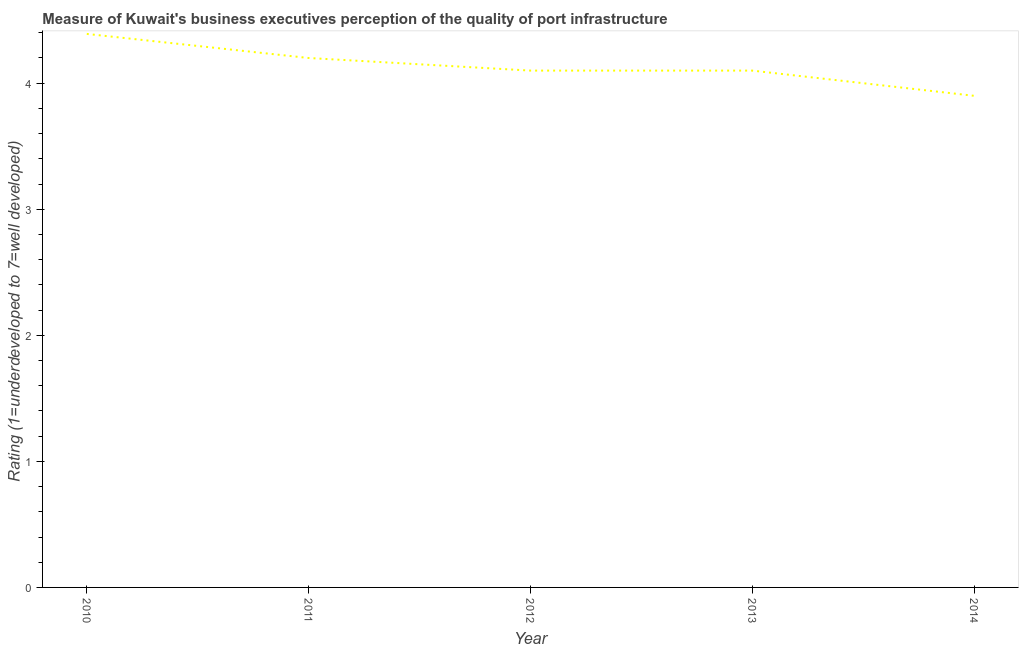Across all years, what is the maximum rating measuring quality of port infrastructure?
Provide a succinct answer. 4.39. Across all years, what is the minimum rating measuring quality of port infrastructure?
Make the answer very short. 3.9. In which year was the rating measuring quality of port infrastructure maximum?
Provide a short and direct response. 2010. What is the sum of the rating measuring quality of port infrastructure?
Your answer should be very brief. 20.69. What is the difference between the rating measuring quality of port infrastructure in 2011 and 2012?
Keep it short and to the point. 0.1. What is the average rating measuring quality of port infrastructure per year?
Provide a succinct answer. 4.14. What is the median rating measuring quality of port infrastructure?
Give a very brief answer. 4.1. In how many years, is the rating measuring quality of port infrastructure greater than 1.6 ?
Offer a terse response. 5. Do a majority of the years between 2010 and 2014 (inclusive) have rating measuring quality of port infrastructure greater than 1.4 ?
Provide a succinct answer. Yes. What is the ratio of the rating measuring quality of port infrastructure in 2012 to that in 2014?
Provide a short and direct response. 1.05. Is the difference between the rating measuring quality of port infrastructure in 2011 and 2014 greater than the difference between any two years?
Offer a terse response. No. What is the difference between the highest and the second highest rating measuring quality of port infrastructure?
Provide a short and direct response. 0.19. What is the difference between the highest and the lowest rating measuring quality of port infrastructure?
Your answer should be very brief. 0.49. In how many years, is the rating measuring quality of port infrastructure greater than the average rating measuring quality of port infrastructure taken over all years?
Offer a terse response. 2. What is the difference between two consecutive major ticks on the Y-axis?
Offer a terse response. 1. Does the graph contain any zero values?
Provide a short and direct response. No. Does the graph contain grids?
Give a very brief answer. No. What is the title of the graph?
Make the answer very short. Measure of Kuwait's business executives perception of the quality of port infrastructure. What is the label or title of the X-axis?
Your response must be concise. Year. What is the label or title of the Y-axis?
Keep it short and to the point. Rating (1=underdeveloped to 7=well developed) . What is the Rating (1=underdeveloped to 7=well developed)  of 2010?
Offer a very short reply. 4.39. What is the Rating (1=underdeveloped to 7=well developed)  in 2011?
Give a very brief answer. 4.2. What is the Rating (1=underdeveloped to 7=well developed)  of 2014?
Provide a succinct answer. 3.9. What is the difference between the Rating (1=underdeveloped to 7=well developed)  in 2010 and 2011?
Keep it short and to the point. 0.19. What is the difference between the Rating (1=underdeveloped to 7=well developed)  in 2010 and 2012?
Your response must be concise. 0.29. What is the difference between the Rating (1=underdeveloped to 7=well developed)  in 2010 and 2013?
Provide a short and direct response. 0.29. What is the difference between the Rating (1=underdeveloped to 7=well developed)  in 2010 and 2014?
Offer a terse response. 0.49. What is the difference between the Rating (1=underdeveloped to 7=well developed)  in 2011 and 2012?
Provide a short and direct response. 0.1. What is the difference between the Rating (1=underdeveloped to 7=well developed)  in 2012 and 2013?
Offer a terse response. 0. What is the difference between the Rating (1=underdeveloped to 7=well developed)  in 2012 and 2014?
Give a very brief answer. 0.2. What is the ratio of the Rating (1=underdeveloped to 7=well developed)  in 2010 to that in 2011?
Make the answer very short. 1.04. What is the ratio of the Rating (1=underdeveloped to 7=well developed)  in 2010 to that in 2012?
Keep it short and to the point. 1.07. What is the ratio of the Rating (1=underdeveloped to 7=well developed)  in 2010 to that in 2013?
Provide a succinct answer. 1.07. What is the ratio of the Rating (1=underdeveloped to 7=well developed)  in 2010 to that in 2014?
Provide a short and direct response. 1.13. What is the ratio of the Rating (1=underdeveloped to 7=well developed)  in 2011 to that in 2013?
Give a very brief answer. 1.02. What is the ratio of the Rating (1=underdeveloped to 7=well developed)  in 2011 to that in 2014?
Ensure brevity in your answer.  1.08. What is the ratio of the Rating (1=underdeveloped to 7=well developed)  in 2012 to that in 2014?
Your answer should be compact. 1.05. What is the ratio of the Rating (1=underdeveloped to 7=well developed)  in 2013 to that in 2014?
Your answer should be compact. 1.05. 